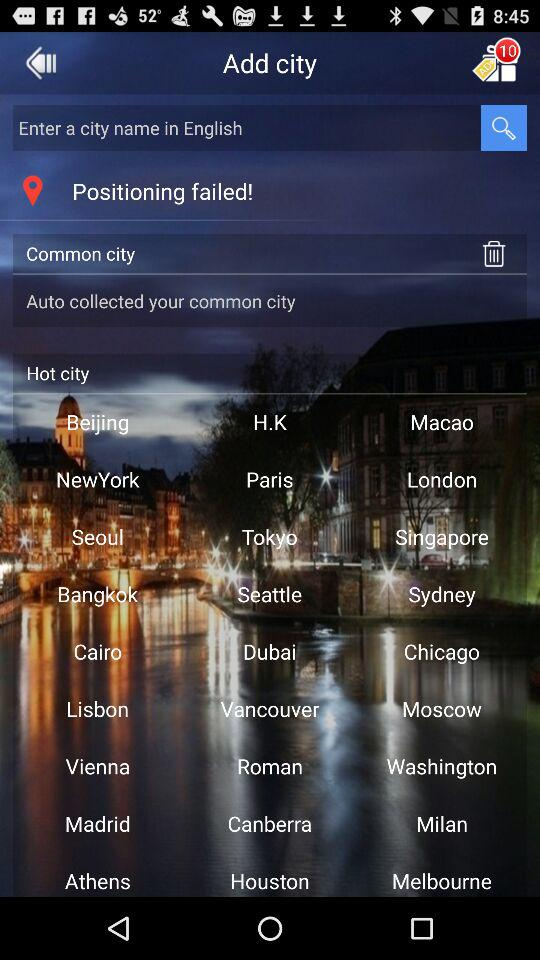In what language can we enter a city name? You can enter a city name in English. 